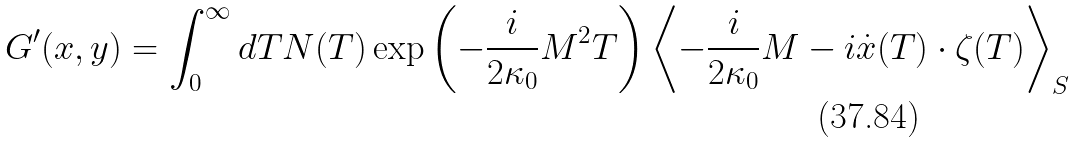<formula> <loc_0><loc_0><loc_500><loc_500>G ^ { \prime } ( x , y ) = \int _ { 0 } ^ { \infty } d T N ( T ) \exp \left ( - \frac { i } { 2 \kappa _ { 0 } } M ^ { 2 } T \right ) \left < - \frac { i } { 2 \kappa _ { 0 } } M - i \dot { x } ( T ) \cdot \zeta ( T ) \right > _ { S }</formula> 